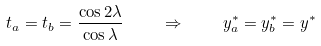<formula> <loc_0><loc_0><loc_500><loc_500>t _ { a } = t _ { b } = \frac { \cos 2 \lambda } { \cos \lambda } \quad \Rightarrow \quad y _ { a } ^ { * } = y _ { b } ^ { * } = y ^ { * }</formula> 